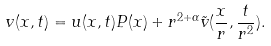Convert formula to latex. <formula><loc_0><loc_0><loc_500><loc_500>v ( x , t ) = u ( x , t ) P ( x ) + r ^ { 2 + \alpha } \tilde { v } ( \frac { x } { r } , \frac { t } { r ^ { 2 } } ) .</formula> 